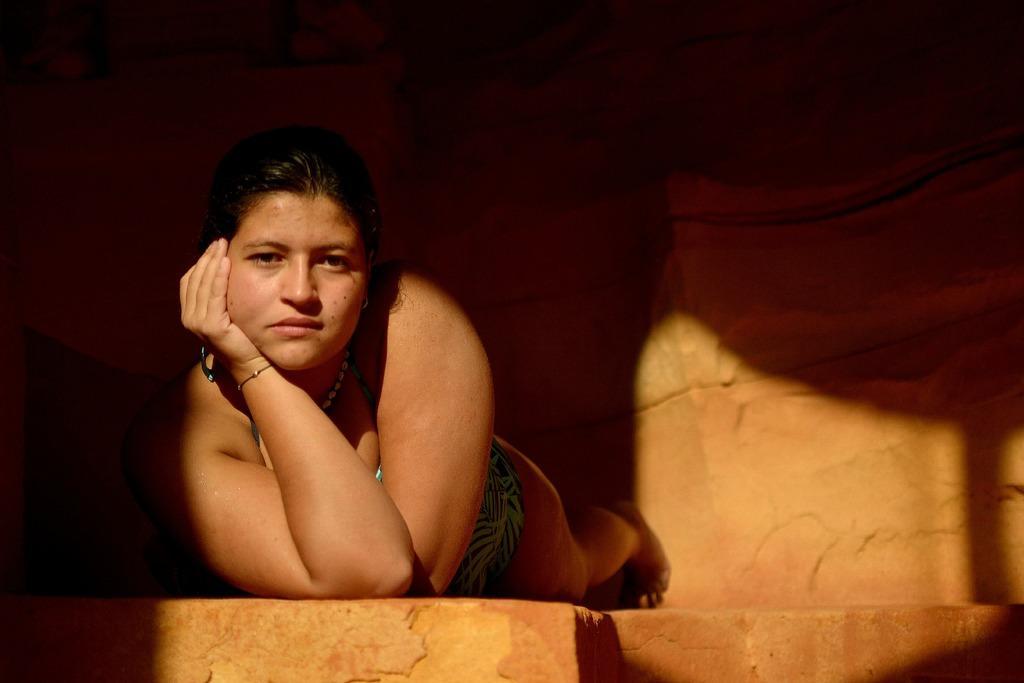Please provide a concise description of this image. In this picture there is a woman lying on the brown rock and giving a pose. Behind there is a brown rock wall. 